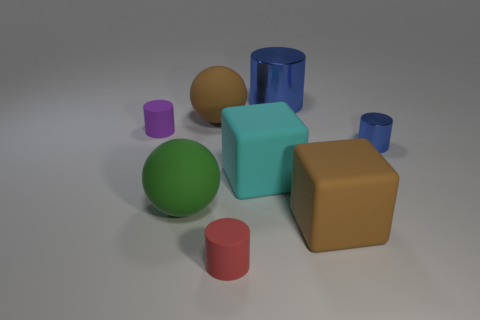The shiny thing in front of the blue cylinder behind the small purple cylinder is what color?
Keep it short and to the point. Blue. There is a small thing that is to the right of the large blue cylinder; is its shape the same as the metallic object to the left of the brown block?
Your response must be concise. Yes. There is a green rubber thing that is the same size as the brown cube; what shape is it?
Ensure brevity in your answer.  Sphere. The other large cube that is the same material as the brown block is what color?
Give a very brief answer. Cyan. Is the shape of the big blue shiny object the same as the brown matte thing on the right side of the red cylinder?
Provide a short and direct response. No. What material is the blue object that is the same size as the green thing?
Offer a very short reply. Metal. Are there any matte spheres that have the same color as the large cylinder?
Keep it short and to the point. No. What shape is the big object that is both left of the large cyan rubber thing and in front of the brown rubber ball?
Ensure brevity in your answer.  Sphere. How many cyan blocks have the same material as the tiny purple cylinder?
Give a very brief answer. 1. Are there fewer small objects to the right of the large blue metallic cylinder than objects that are in front of the small blue object?
Give a very brief answer. Yes. 